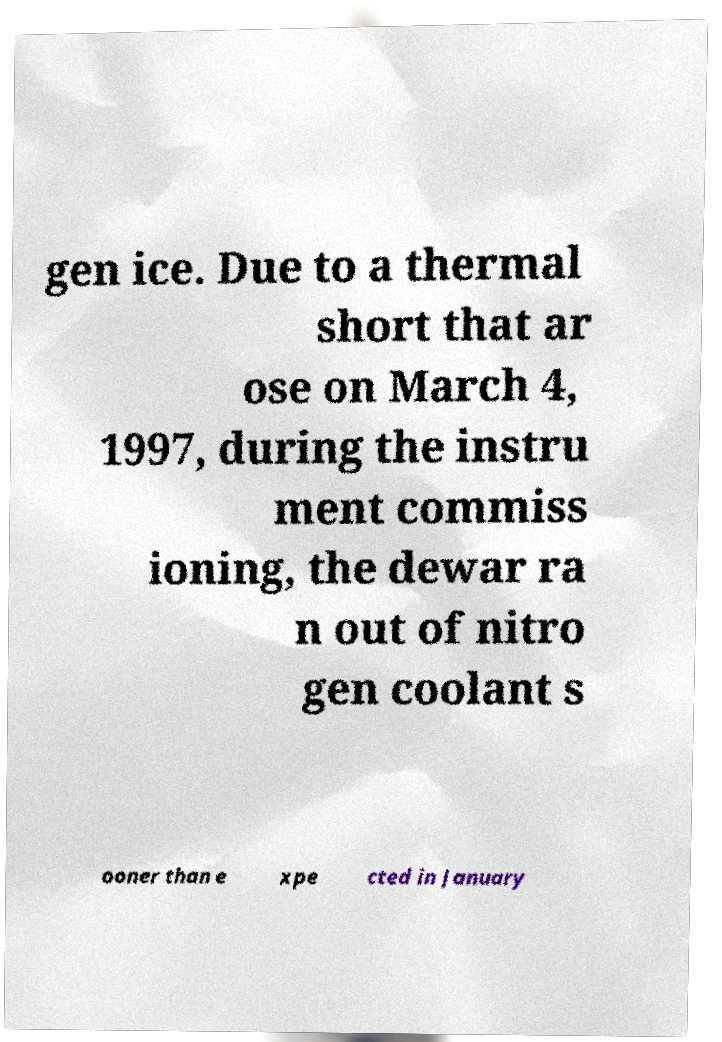Could you extract and type out the text from this image? gen ice. Due to a thermal short that ar ose on March 4, 1997, during the instru ment commiss ioning, the dewar ra n out of nitro gen coolant s ooner than e xpe cted in January 